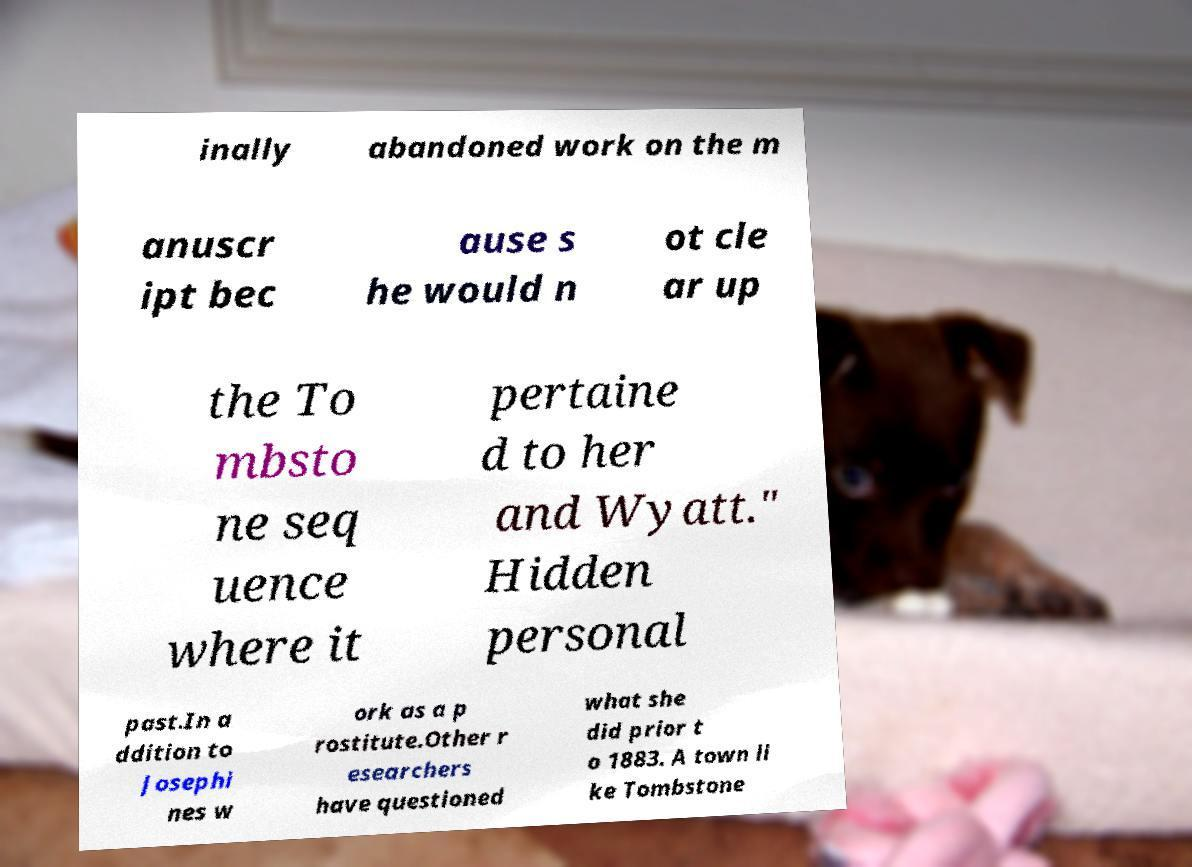There's text embedded in this image that I need extracted. Can you transcribe it verbatim? inally abandoned work on the m anuscr ipt bec ause s he would n ot cle ar up the To mbsto ne seq uence where it pertaine d to her and Wyatt." Hidden personal past.In a ddition to Josephi nes w ork as a p rostitute.Other r esearchers have questioned what she did prior t o 1883. A town li ke Tombstone 